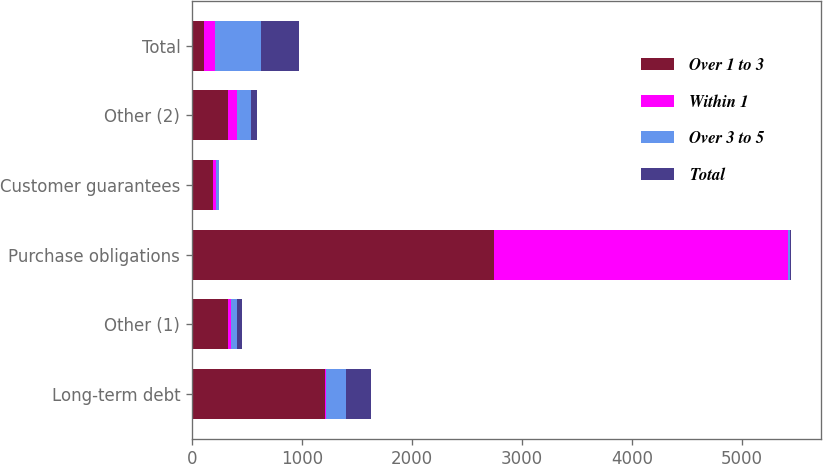Convert chart to OTSL. <chart><loc_0><loc_0><loc_500><loc_500><stacked_bar_chart><ecel><fcel>Long-term debt<fcel>Other (1)<fcel>Purchase obligations<fcel>Customer guarantees<fcel>Other (2)<fcel>Total<nl><fcel>Over 1 to 3<fcel>1208.1<fcel>325.7<fcel>2742.1<fcel>189.8<fcel>323.3<fcel>105.7<nl><fcel>Within 1<fcel>7.8<fcel>27.9<fcel>2681.9<fcel>24.2<fcel>87.9<fcel>105.7<nl><fcel>Over 3 to 5<fcel>184.4<fcel>56<fcel>15.6<fcel>33.9<fcel>123.5<fcel>413.4<nl><fcel>Total<fcel>230.7<fcel>49.3<fcel>12.5<fcel>1.7<fcel>53.2<fcel>347.4<nl></chart> 